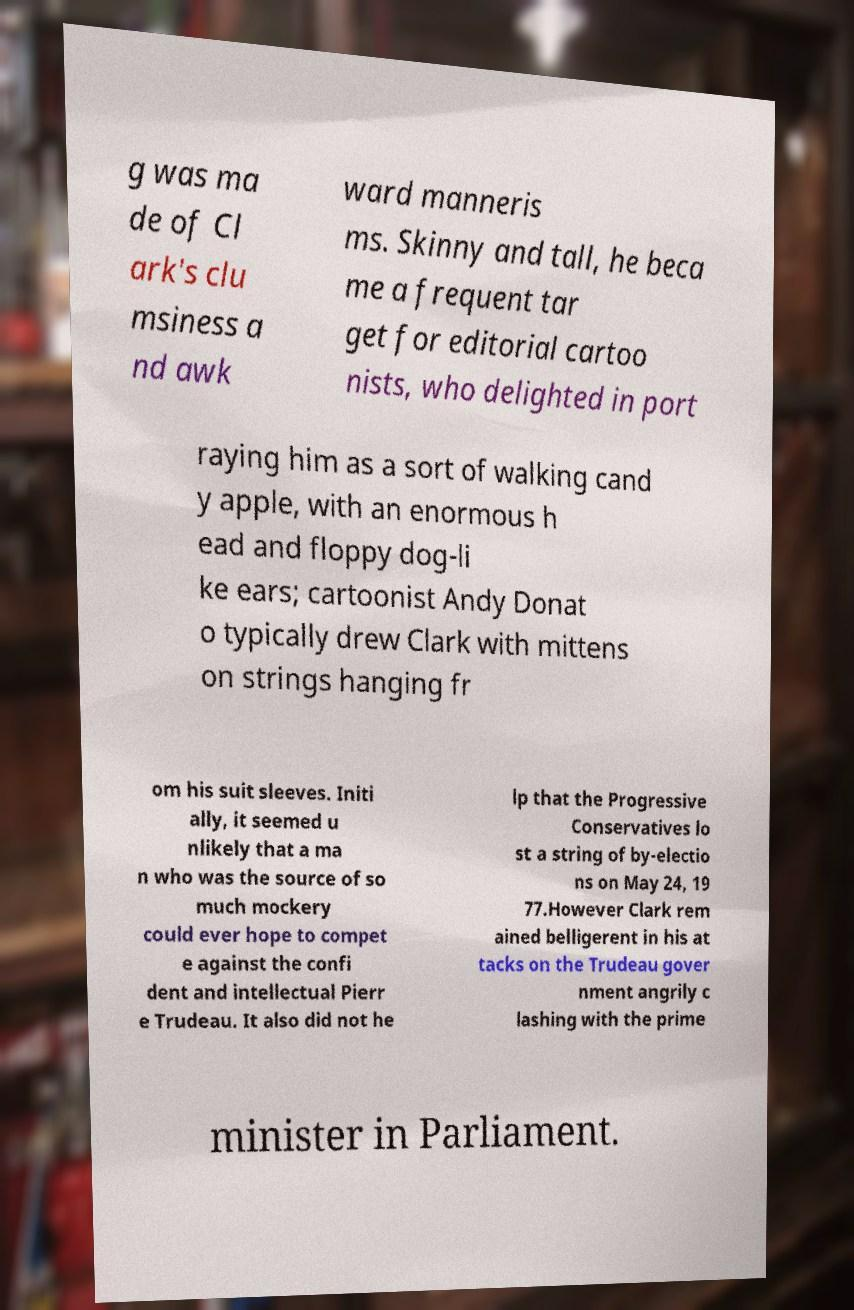For documentation purposes, I need the text within this image transcribed. Could you provide that? g was ma de of Cl ark's clu msiness a nd awk ward manneris ms. Skinny and tall, he beca me a frequent tar get for editorial cartoo nists, who delighted in port raying him as a sort of walking cand y apple, with an enormous h ead and floppy dog-li ke ears; cartoonist Andy Donat o typically drew Clark with mittens on strings hanging fr om his suit sleeves. Initi ally, it seemed u nlikely that a ma n who was the source of so much mockery could ever hope to compet e against the confi dent and intellectual Pierr e Trudeau. It also did not he lp that the Progressive Conservatives lo st a string of by-electio ns on May 24, 19 77.However Clark rem ained belligerent in his at tacks on the Trudeau gover nment angrily c lashing with the prime minister in Parliament. 